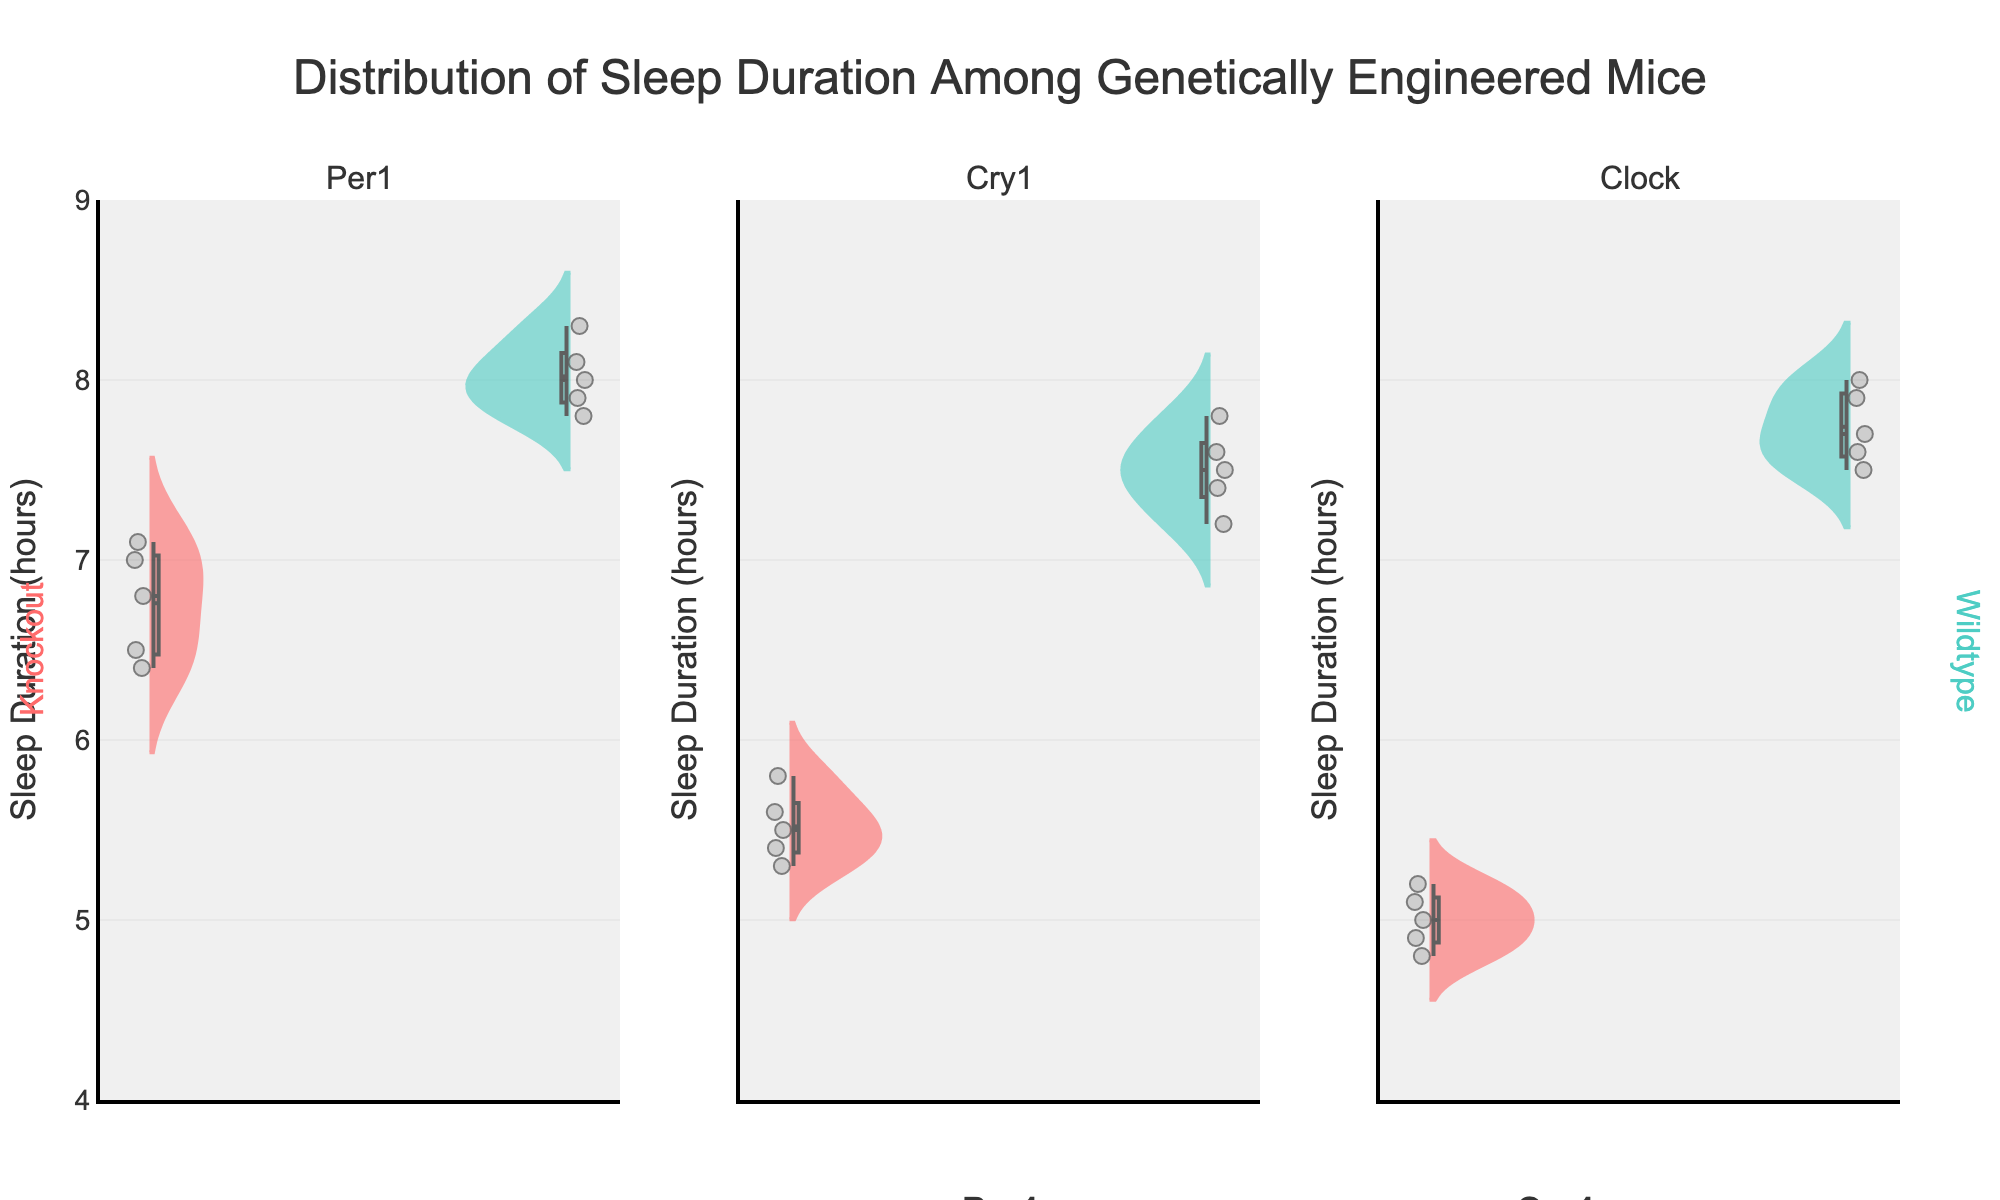What's the title of the figure? The title is prominently displayed at the top of the figure, and it provides a clear summary of what the figure represents.
Answer: Distribution of Sleep Duration Among Genetically Engineered Mice What is the y-axis label on the figure? The y-axis label is located along the vertical axis of the figure and indicates the measurement used.
Answer: Sleep Duration (hours) How many groups are shown for each gene type in the figure? By visually counting, there are two groups (Knockout and Wildtype) shown for each gene type.
Answer: 2 Which group shows the highest average sleep duration for the Per1 gene? For the Per1 gene, compare the mean lines of both groups (Knockout and Wildtype). The group with the higher mean line indicates the higher average sleep duration.
Answer: Wildtype Is there a significant difference in sleep duration between Knockout and Wildtype mice for the Clock gene? By comparing the mean lines and the spread of distributions for the Knockout and Wildtype groups in the Clock gene subplot, you can observe that the Wildtype group has higher sleep duration with distinct separation from the Knockout group.
Answer: Yes, Wildtype has a higher sleep duration What's the range of sleep duration observed in the Cry1 Knockout group? The range is determined by the minimum and maximum points of the Cry1 Knockout group's distribution. The smallest and largest values indicate the range.
Answer: 5.3 to 5.8 hours How does the variability in sleep duration compare between Clock Knockout and Clock Wildtype groups? Compare the spread (width) of the distributions in the Clock gene subplot. The group with a smaller spread has lower variability and vice versa.
Answer: Clock Wildtype has less variability For the Per1 gene, which group has more data points? Count the individual data points displayed within each group's distribution in the Per1 gene subplot.
Answer: Both have the same number of data points Which gene has the smallest range in sleep duration for its Knockout group? By comparing the length of the distributions from minimum to maximum sleep duration for all Knockout groups, identify the gene with the smallest range.
Answer: Cry1 What's the average range of sleep duration for the Wildtype groups across all genes? Calculate the range for each Wildtype group, then compute the average of these ranges. Wildtype ranges are Per1 (0.5), Cry1 (0.6), and Clock (0.5). (0.5+0.6+0.5) / 3 = 0.53
Answer: 0.53 hours 